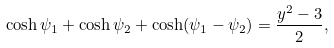<formula> <loc_0><loc_0><loc_500><loc_500>\cosh \psi _ { 1 } + \cosh \psi _ { 2 } + \cosh ( \psi _ { 1 } - \psi _ { 2 } ) = \frac { y ^ { 2 } - 3 } { 2 } ,</formula> 